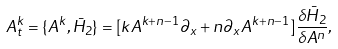Convert formula to latex. <formula><loc_0><loc_0><loc_500><loc_500>A _ { t } ^ { k } = \{ A ^ { k } , \bar { H } _ { 2 } \} = [ k A ^ { k + n - 1 } \partial _ { x } + n \partial _ { x } A ^ { k + n - 1 } ] \frac { \delta \bar { H } _ { 2 } } { \delta A ^ { n } } ,</formula> 